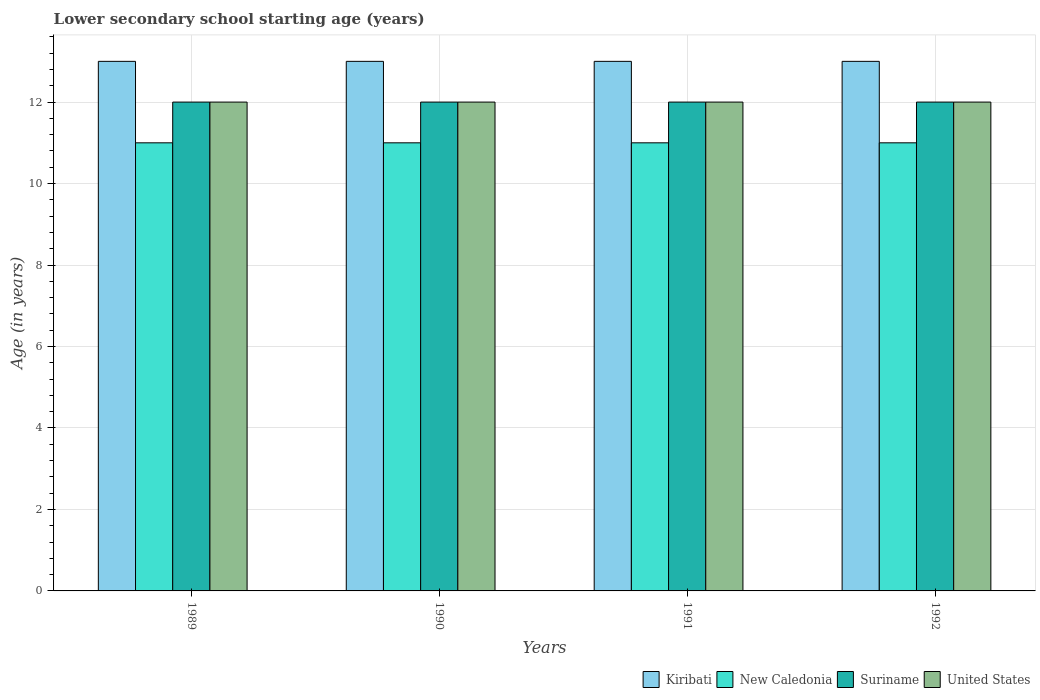How many different coloured bars are there?
Your answer should be compact. 4. How many groups of bars are there?
Offer a terse response. 4. Are the number of bars per tick equal to the number of legend labels?
Offer a terse response. Yes. How many bars are there on the 2nd tick from the left?
Your answer should be very brief. 4. In how many cases, is the number of bars for a given year not equal to the number of legend labels?
Provide a short and direct response. 0. What is the lower secondary school starting age of children in New Caledonia in 1991?
Your response must be concise. 11. Across all years, what is the maximum lower secondary school starting age of children in United States?
Keep it short and to the point. 12. Across all years, what is the minimum lower secondary school starting age of children in Suriname?
Offer a terse response. 12. In which year was the lower secondary school starting age of children in Suriname minimum?
Offer a very short reply. 1989. What is the total lower secondary school starting age of children in New Caledonia in the graph?
Your response must be concise. 44. What is the difference between the lower secondary school starting age of children in Suriname in 1989 and that in 1992?
Provide a short and direct response. 0. What is the average lower secondary school starting age of children in Suriname per year?
Provide a succinct answer. 12. In the year 1989, what is the difference between the lower secondary school starting age of children in Kiribati and lower secondary school starting age of children in New Caledonia?
Your response must be concise. 2. In how many years, is the lower secondary school starting age of children in Suriname greater than 6 years?
Your answer should be compact. 4. Is the lower secondary school starting age of children in Suriname in 1989 less than that in 1990?
Offer a very short reply. No. In how many years, is the lower secondary school starting age of children in New Caledonia greater than the average lower secondary school starting age of children in New Caledonia taken over all years?
Ensure brevity in your answer.  0. Is the sum of the lower secondary school starting age of children in Suriname in 1990 and 1992 greater than the maximum lower secondary school starting age of children in New Caledonia across all years?
Your answer should be compact. Yes. What does the 3rd bar from the left in 1989 represents?
Provide a succinct answer. Suriname. What does the 4th bar from the right in 1990 represents?
Your answer should be compact. Kiribati. How many years are there in the graph?
Provide a short and direct response. 4. Are the values on the major ticks of Y-axis written in scientific E-notation?
Offer a very short reply. No. Where does the legend appear in the graph?
Provide a succinct answer. Bottom right. How many legend labels are there?
Give a very brief answer. 4. How are the legend labels stacked?
Your answer should be very brief. Horizontal. What is the title of the graph?
Your answer should be very brief. Lower secondary school starting age (years). Does "Low & middle income" appear as one of the legend labels in the graph?
Give a very brief answer. No. What is the label or title of the X-axis?
Your answer should be very brief. Years. What is the label or title of the Y-axis?
Provide a succinct answer. Age (in years). What is the Age (in years) in United States in 1989?
Make the answer very short. 12. What is the Age (in years) of Kiribati in 1990?
Give a very brief answer. 13. What is the Age (in years) of Suriname in 1990?
Your answer should be compact. 12. What is the Age (in years) in United States in 1990?
Give a very brief answer. 12. What is the Age (in years) of Suriname in 1991?
Make the answer very short. 12. What is the Age (in years) in United States in 1991?
Make the answer very short. 12. What is the Age (in years) in Suriname in 1992?
Provide a succinct answer. 12. What is the Age (in years) in United States in 1992?
Keep it short and to the point. 12. Across all years, what is the maximum Age (in years) in Kiribati?
Offer a terse response. 13. Across all years, what is the maximum Age (in years) in New Caledonia?
Provide a short and direct response. 11. Across all years, what is the maximum Age (in years) in Suriname?
Provide a succinct answer. 12. Across all years, what is the maximum Age (in years) of United States?
Ensure brevity in your answer.  12. Across all years, what is the minimum Age (in years) of Suriname?
Your answer should be compact. 12. Across all years, what is the minimum Age (in years) in United States?
Provide a succinct answer. 12. What is the total Age (in years) of United States in the graph?
Keep it short and to the point. 48. What is the difference between the Age (in years) in Suriname in 1989 and that in 1990?
Give a very brief answer. 0. What is the difference between the Age (in years) in United States in 1989 and that in 1990?
Offer a terse response. 0. What is the difference between the Age (in years) of United States in 1989 and that in 1991?
Provide a succinct answer. 0. What is the difference between the Age (in years) of Kiribati in 1989 and that in 1992?
Offer a very short reply. 0. What is the difference between the Age (in years) of New Caledonia in 1989 and that in 1992?
Offer a very short reply. 0. What is the difference between the Age (in years) of Suriname in 1989 and that in 1992?
Make the answer very short. 0. What is the difference between the Age (in years) of New Caledonia in 1990 and that in 1991?
Offer a terse response. 0. What is the difference between the Age (in years) of United States in 1990 and that in 1991?
Provide a short and direct response. 0. What is the difference between the Age (in years) in Kiribati in 1990 and that in 1992?
Your answer should be compact. 0. What is the difference between the Age (in years) in New Caledonia in 1990 and that in 1992?
Your answer should be very brief. 0. What is the difference between the Age (in years) in United States in 1990 and that in 1992?
Provide a succinct answer. 0. What is the difference between the Age (in years) in United States in 1991 and that in 1992?
Make the answer very short. 0. What is the difference between the Age (in years) of Kiribati in 1989 and the Age (in years) of United States in 1990?
Offer a terse response. 1. What is the difference between the Age (in years) in New Caledonia in 1989 and the Age (in years) in Suriname in 1990?
Ensure brevity in your answer.  -1. What is the difference between the Age (in years) in New Caledonia in 1989 and the Age (in years) in United States in 1990?
Make the answer very short. -1. What is the difference between the Age (in years) of Kiribati in 1989 and the Age (in years) of United States in 1991?
Offer a very short reply. 1. What is the difference between the Age (in years) of New Caledonia in 1989 and the Age (in years) of United States in 1991?
Your answer should be very brief. -1. What is the difference between the Age (in years) in New Caledonia in 1989 and the Age (in years) in Suriname in 1992?
Provide a succinct answer. -1. What is the difference between the Age (in years) of New Caledonia in 1989 and the Age (in years) of United States in 1992?
Your response must be concise. -1. What is the difference between the Age (in years) of Suriname in 1989 and the Age (in years) of United States in 1992?
Your answer should be compact. 0. What is the difference between the Age (in years) in Kiribati in 1990 and the Age (in years) in New Caledonia in 1991?
Give a very brief answer. 2. What is the difference between the Age (in years) of Kiribati in 1990 and the Age (in years) of Suriname in 1991?
Ensure brevity in your answer.  1. What is the difference between the Age (in years) in Kiribati in 1990 and the Age (in years) in United States in 1991?
Offer a terse response. 1. What is the difference between the Age (in years) in New Caledonia in 1990 and the Age (in years) in Suriname in 1991?
Give a very brief answer. -1. What is the difference between the Age (in years) of New Caledonia in 1990 and the Age (in years) of United States in 1991?
Your response must be concise. -1. What is the difference between the Age (in years) in New Caledonia in 1990 and the Age (in years) in Suriname in 1992?
Your answer should be compact. -1. What is the difference between the Age (in years) of New Caledonia in 1990 and the Age (in years) of United States in 1992?
Provide a short and direct response. -1. What is the difference between the Age (in years) of Kiribati in 1991 and the Age (in years) of New Caledonia in 1992?
Provide a succinct answer. 2. What is the difference between the Age (in years) in Kiribati in 1991 and the Age (in years) in Suriname in 1992?
Provide a short and direct response. 1. What is the difference between the Age (in years) in Kiribati in 1991 and the Age (in years) in United States in 1992?
Keep it short and to the point. 1. What is the difference between the Age (in years) in New Caledonia in 1991 and the Age (in years) in United States in 1992?
Your answer should be very brief. -1. What is the difference between the Age (in years) in Suriname in 1991 and the Age (in years) in United States in 1992?
Provide a short and direct response. 0. What is the average Age (in years) of Kiribati per year?
Offer a very short reply. 13. What is the average Age (in years) of New Caledonia per year?
Your response must be concise. 11. What is the average Age (in years) of Suriname per year?
Your answer should be compact. 12. What is the average Age (in years) of United States per year?
Offer a terse response. 12. In the year 1989, what is the difference between the Age (in years) in Kiribati and Age (in years) in New Caledonia?
Offer a very short reply. 2. In the year 1989, what is the difference between the Age (in years) of Kiribati and Age (in years) of Suriname?
Your answer should be very brief. 1. In the year 1989, what is the difference between the Age (in years) in Kiribati and Age (in years) in United States?
Ensure brevity in your answer.  1. In the year 1989, what is the difference between the Age (in years) in New Caledonia and Age (in years) in Suriname?
Your answer should be very brief. -1. In the year 1990, what is the difference between the Age (in years) in Kiribati and Age (in years) in New Caledonia?
Ensure brevity in your answer.  2. In the year 1990, what is the difference between the Age (in years) in Kiribati and Age (in years) in Suriname?
Ensure brevity in your answer.  1. In the year 1990, what is the difference between the Age (in years) of New Caledonia and Age (in years) of United States?
Ensure brevity in your answer.  -1. In the year 1991, what is the difference between the Age (in years) in Kiribati and Age (in years) in New Caledonia?
Your answer should be compact. 2. In the year 1991, what is the difference between the Age (in years) of Kiribati and Age (in years) of Suriname?
Provide a short and direct response. 1. In the year 1992, what is the difference between the Age (in years) of Kiribati and Age (in years) of Suriname?
Your response must be concise. 1. In the year 1992, what is the difference between the Age (in years) of New Caledonia and Age (in years) of Suriname?
Provide a short and direct response. -1. What is the ratio of the Age (in years) of New Caledonia in 1989 to that in 1990?
Your answer should be very brief. 1. What is the ratio of the Age (in years) in Suriname in 1989 to that in 1990?
Keep it short and to the point. 1. What is the ratio of the Age (in years) in Kiribati in 1989 to that in 1991?
Keep it short and to the point. 1. What is the ratio of the Age (in years) in New Caledonia in 1989 to that in 1992?
Offer a terse response. 1. What is the ratio of the Age (in years) in Kiribati in 1990 to that in 1991?
Make the answer very short. 1. What is the ratio of the Age (in years) of New Caledonia in 1990 to that in 1991?
Make the answer very short. 1. What is the ratio of the Age (in years) in Suriname in 1990 to that in 1992?
Offer a very short reply. 1. What is the ratio of the Age (in years) of Kiribati in 1991 to that in 1992?
Provide a succinct answer. 1. What is the ratio of the Age (in years) in United States in 1991 to that in 1992?
Provide a short and direct response. 1. What is the difference between the highest and the second highest Age (in years) in New Caledonia?
Your answer should be very brief. 0. What is the difference between the highest and the second highest Age (in years) in Suriname?
Provide a succinct answer. 0. What is the difference between the highest and the lowest Age (in years) in Suriname?
Offer a very short reply. 0. What is the difference between the highest and the lowest Age (in years) of United States?
Make the answer very short. 0. 